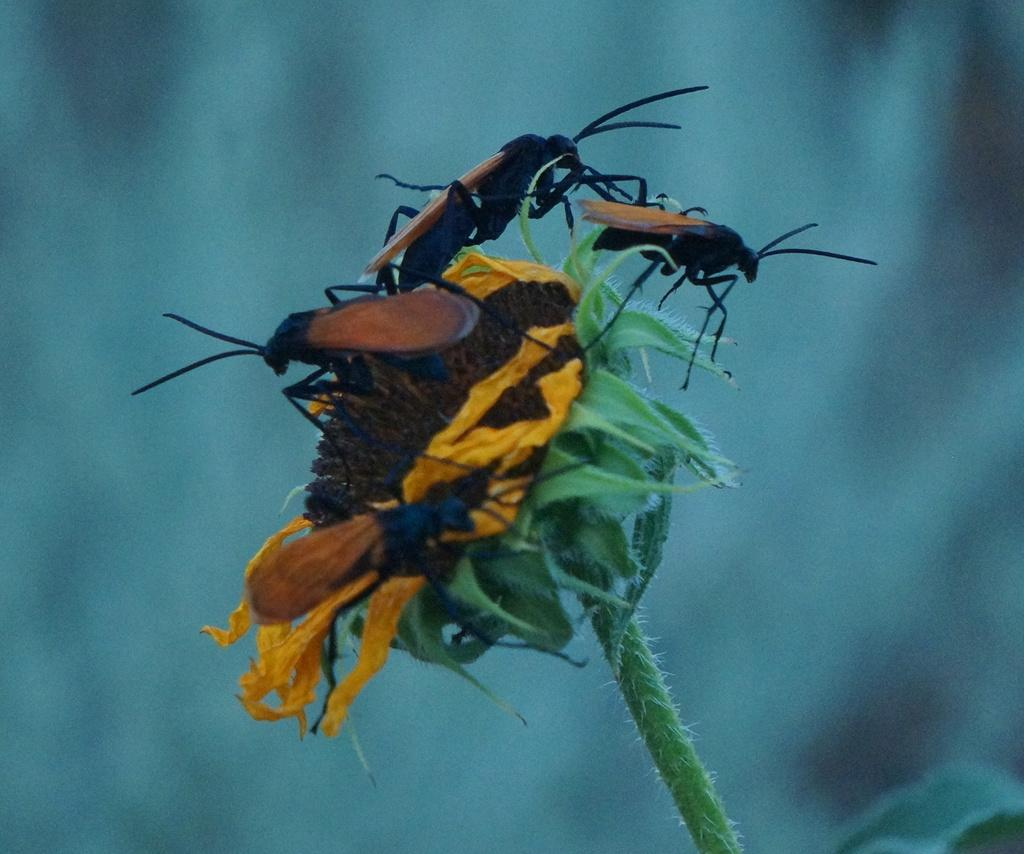What is happening on the flower in the image? There are insects on a flower in the image. What can be seen behind the flower? The background of the image is visible. How does the cat burst into the image? There is no cat present in the image, so it cannot burst into the image. 